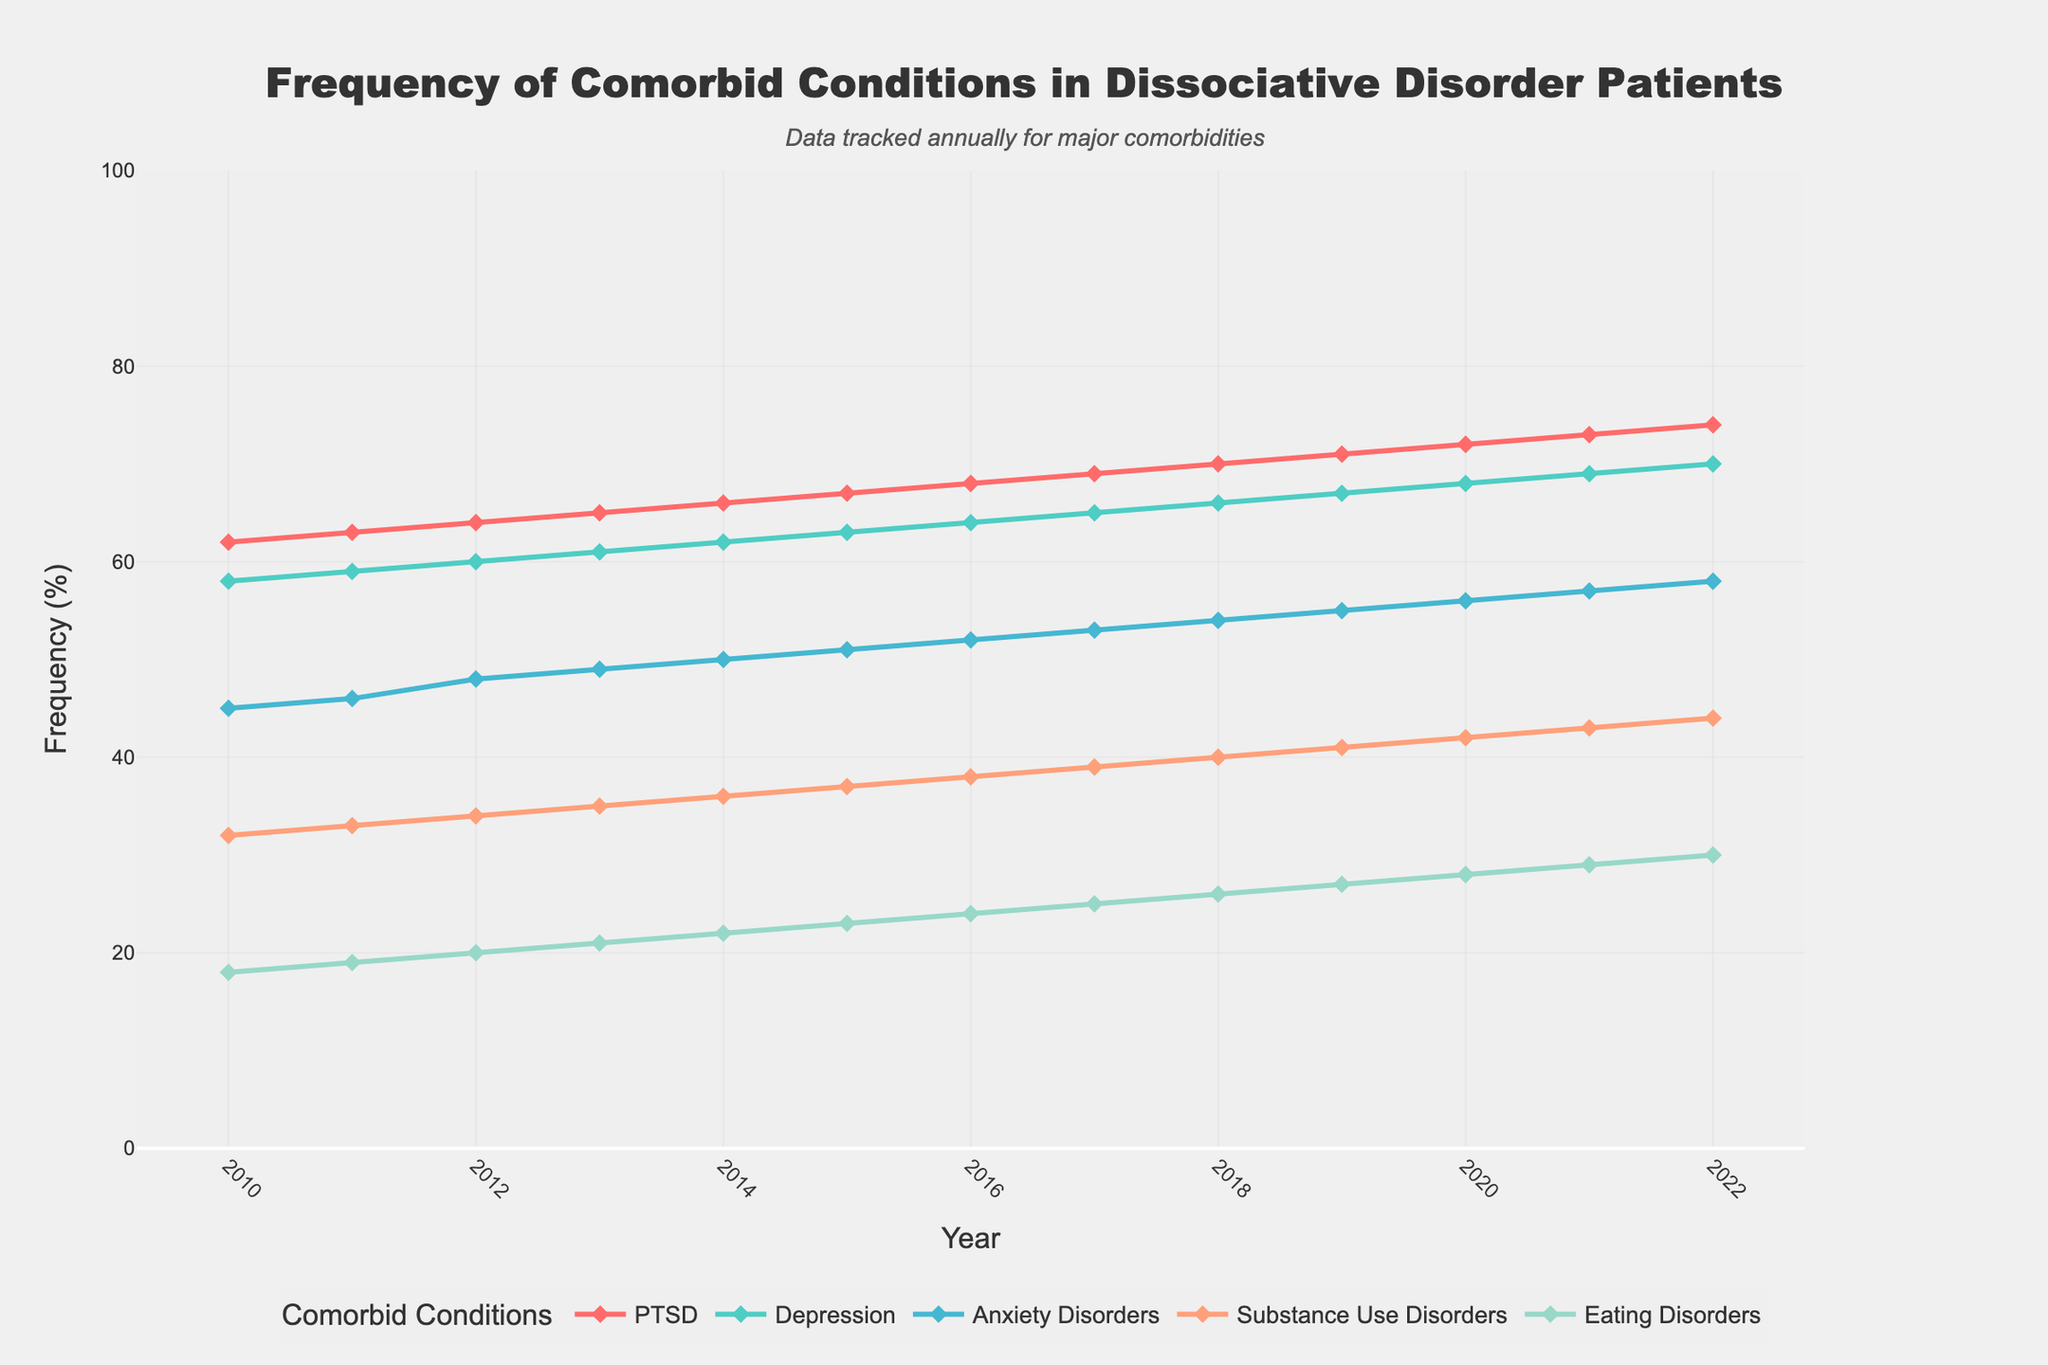What's the trend for PTSD frequency from 2010 to 2022? From the figure, identify the line corresponding to PTSD, then observe its general direction. It starts at 62% in 2010 and steadily increases every year, reaching 74% in 2022.
Answer: Increasing Compare the frequency of Depression and Anxiety Disorders in 2020. Which condition is more frequent? Look at the values for Depression and Anxiety Disorders in the year 2020. Depression has a frequency of 68%, while Anxiety Disorders have a frequency of 56%. Therefore, Depression is more frequent than Anxiety Disorders in 2020.
Answer: Depression In what year did Substance Use Disorders reach a frequency of 35%? Examine the Substance Use Disorders line and locate the year when it intersects with 35%. In 2013, the line for Substance Use Disorders intersects with 35%.
Answer: 2013 Which condition consistently showed the lowest frequency throughout the years? In the figure, identify the line that is always at the lowest position compared to others across all years. The line for Eating Disorders is consistently the lowest.
Answer: Eating Disorders What's the difference in the frequency of Substance Use Disorders from 2012 to 2016? Note the frequency values of Substance Use Disorders in 2012 (34%) and 2016 (38%). Subtract the 2012 value from the 2016 value: 38% - 34% = 4%.
Answer: 4% By how much did the frequency of PTSD increase from 2010 to 2022? Examine the frequency values for PTSD in 2010 (62%) and 2022 (74%). Subtract the 2010 value from the 2022 value: 74% - 62% = 12%.
Answer: 12% Is Anxiety Disorders' rate of increase faster or slower than Depression's from 2010 to 2022? Calculate the increase for both conditions from 2010 to 2022. Anxiety Disorders: 58% - 45% = 13%. Depression: 70% - 58% = 12%. Compare the two increases: 13% > 12% indicates that Anxiety Disorders' rate of increase is faster.
Answer: Faster What year did Eating Disorders show a frequency change greater than 1% year-over-year? Identify the Eating Disorders line and look for a year-to-year increase of more than 1%. For instance, from 2017 (25%) to 2018 (26%) is an increase of 1%, but from 2018 (26%) to 2019 (27%) is also 1%, which is not greater than 1%. However, it never exceeds 1% year-over-year.
Answer: None 